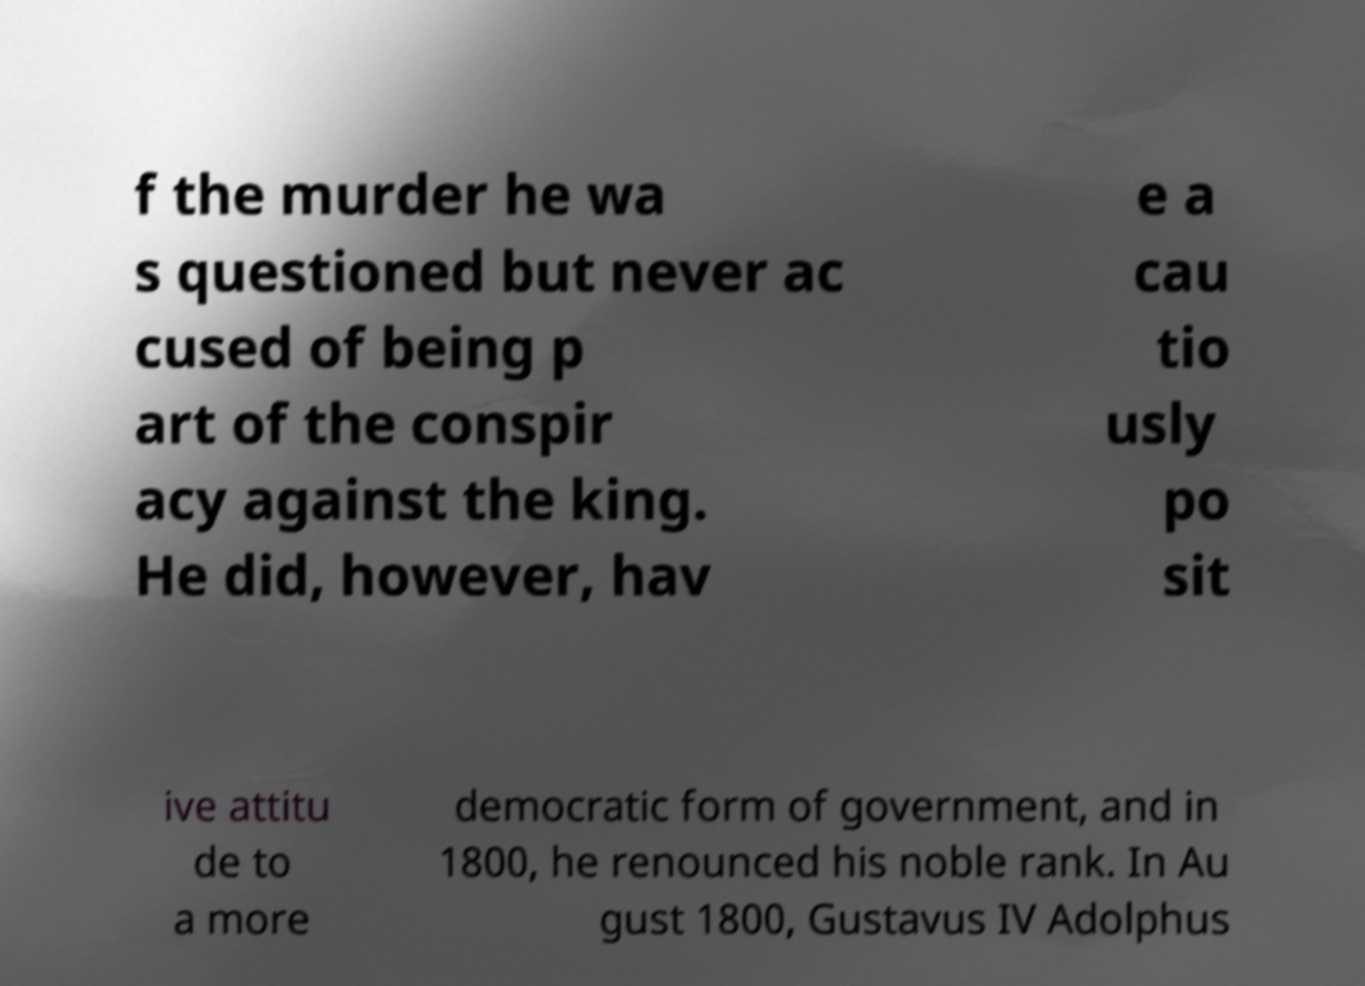I need the written content from this picture converted into text. Can you do that? f the murder he wa s questioned but never ac cused of being p art of the conspir acy against the king. He did, however, hav e a cau tio usly po sit ive attitu de to a more democratic form of government, and in 1800, he renounced his noble rank. In Au gust 1800, Gustavus IV Adolphus 